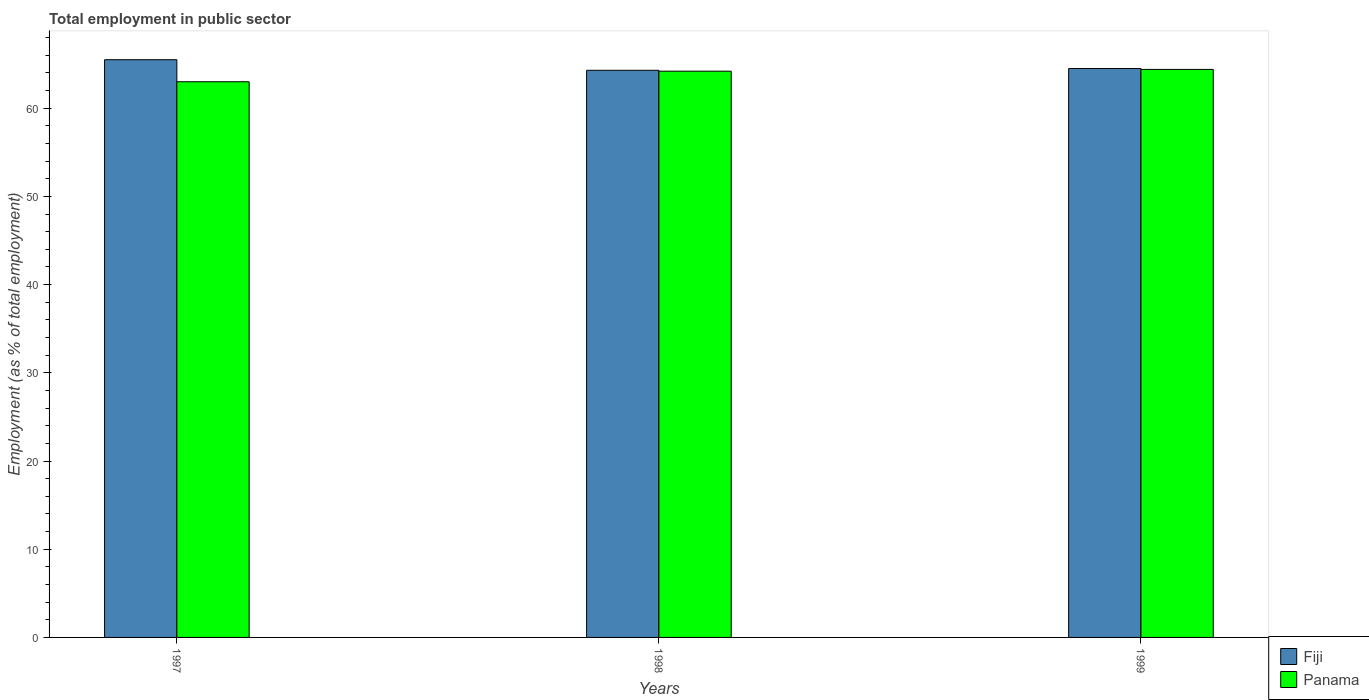How many groups of bars are there?
Your response must be concise. 3. Are the number of bars per tick equal to the number of legend labels?
Offer a terse response. Yes. How many bars are there on the 3rd tick from the left?
Ensure brevity in your answer.  2. How many bars are there on the 1st tick from the right?
Make the answer very short. 2. What is the employment in public sector in Panama in 1999?
Offer a terse response. 64.4. Across all years, what is the maximum employment in public sector in Fiji?
Offer a terse response. 65.5. Across all years, what is the minimum employment in public sector in Fiji?
Your answer should be compact. 64.3. In which year was the employment in public sector in Fiji maximum?
Ensure brevity in your answer.  1997. In which year was the employment in public sector in Fiji minimum?
Provide a succinct answer. 1998. What is the total employment in public sector in Panama in the graph?
Your response must be concise. 191.6. What is the difference between the employment in public sector in Panama in 1997 and that in 1998?
Offer a terse response. -1.2. What is the difference between the employment in public sector in Panama in 1998 and the employment in public sector in Fiji in 1999?
Your response must be concise. -0.3. What is the average employment in public sector in Fiji per year?
Make the answer very short. 64.77. In the year 1998, what is the difference between the employment in public sector in Panama and employment in public sector in Fiji?
Your response must be concise. -0.1. In how many years, is the employment in public sector in Panama greater than 10 %?
Ensure brevity in your answer.  3. What is the ratio of the employment in public sector in Fiji in 1997 to that in 1998?
Your answer should be very brief. 1.02. Is the employment in public sector in Fiji in 1997 less than that in 1998?
Make the answer very short. No. Is the difference between the employment in public sector in Panama in 1997 and 1999 greater than the difference between the employment in public sector in Fiji in 1997 and 1999?
Give a very brief answer. No. What is the difference between the highest and the second highest employment in public sector in Panama?
Offer a terse response. 0.2. What is the difference between the highest and the lowest employment in public sector in Panama?
Give a very brief answer. 1.4. In how many years, is the employment in public sector in Panama greater than the average employment in public sector in Panama taken over all years?
Your answer should be very brief. 2. Is the sum of the employment in public sector in Fiji in 1997 and 1998 greater than the maximum employment in public sector in Panama across all years?
Offer a very short reply. Yes. What does the 1st bar from the left in 1997 represents?
Your answer should be compact. Fiji. What does the 2nd bar from the right in 1998 represents?
Give a very brief answer. Fiji. Are all the bars in the graph horizontal?
Keep it short and to the point. No. How many years are there in the graph?
Your answer should be very brief. 3. What is the difference between two consecutive major ticks on the Y-axis?
Your response must be concise. 10. Does the graph contain grids?
Provide a succinct answer. No. Where does the legend appear in the graph?
Offer a very short reply. Bottom right. How many legend labels are there?
Make the answer very short. 2. How are the legend labels stacked?
Offer a terse response. Vertical. What is the title of the graph?
Ensure brevity in your answer.  Total employment in public sector. What is the label or title of the Y-axis?
Ensure brevity in your answer.  Employment (as % of total employment). What is the Employment (as % of total employment) in Fiji in 1997?
Provide a succinct answer. 65.5. What is the Employment (as % of total employment) in Panama in 1997?
Ensure brevity in your answer.  63. What is the Employment (as % of total employment) of Fiji in 1998?
Give a very brief answer. 64.3. What is the Employment (as % of total employment) of Panama in 1998?
Make the answer very short. 64.2. What is the Employment (as % of total employment) of Fiji in 1999?
Your answer should be very brief. 64.5. What is the Employment (as % of total employment) in Panama in 1999?
Your answer should be very brief. 64.4. Across all years, what is the maximum Employment (as % of total employment) of Fiji?
Offer a terse response. 65.5. Across all years, what is the maximum Employment (as % of total employment) in Panama?
Ensure brevity in your answer.  64.4. Across all years, what is the minimum Employment (as % of total employment) in Fiji?
Give a very brief answer. 64.3. Across all years, what is the minimum Employment (as % of total employment) in Panama?
Keep it short and to the point. 63. What is the total Employment (as % of total employment) in Fiji in the graph?
Keep it short and to the point. 194.3. What is the total Employment (as % of total employment) in Panama in the graph?
Keep it short and to the point. 191.6. What is the difference between the Employment (as % of total employment) of Panama in 1997 and that in 1998?
Give a very brief answer. -1.2. What is the difference between the Employment (as % of total employment) of Fiji in 1997 and that in 1999?
Your answer should be very brief. 1. What is the difference between the Employment (as % of total employment) in Panama in 1997 and that in 1999?
Your response must be concise. -1.4. What is the difference between the Employment (as % of total employment) of Fiji in 1998 and that in 1999?
Offer a terse response. -0.2. What is the average Employment (as % of total employment) in Fiji per year?
Your answer should be compact. 64.77. What is the average Employment (as % of total employment) in Panama per year?
Make the answer very short. 63.87. In the year 1997, what is the difference between the Employment (as % of total employment) of Fiji and Employment (as % of total employment) of Panama?
Make the answer very short. 2.5. In the year 1999, what is the difference between the Employment (as % of total employment) in Fiji and Employment (as % of total employment) in Panama?
Provide a short and direct response. 0.1. What is the ratio of the Employment (as % of total employment) in Fiji in 1997 to that in 1998?
Keep it short and to the point. 1.02. What is the ratio of the Employment (as % of total employment) in Panama in 1997 to that in 1998?
Keep it short and to the point. 0.98. What is the ratio of the Employment (as % of total employment) of Fiji in 1997 to that in 1999?
Your answer should be very brief. 1.02. What is the ratio of the Employment (as % of total employment) in Panama in 1997 to that in 1999?
Your answer should be very brief. 0.98. What is the difference between the highest and the second highest Employment (as % of total employment) in Fiji?
Keep it short and to the point. 1. What is the difference between the highest and the lowest Employment (as % of total employment) in Fiji?
Keep it short and to the point. 1.2. 